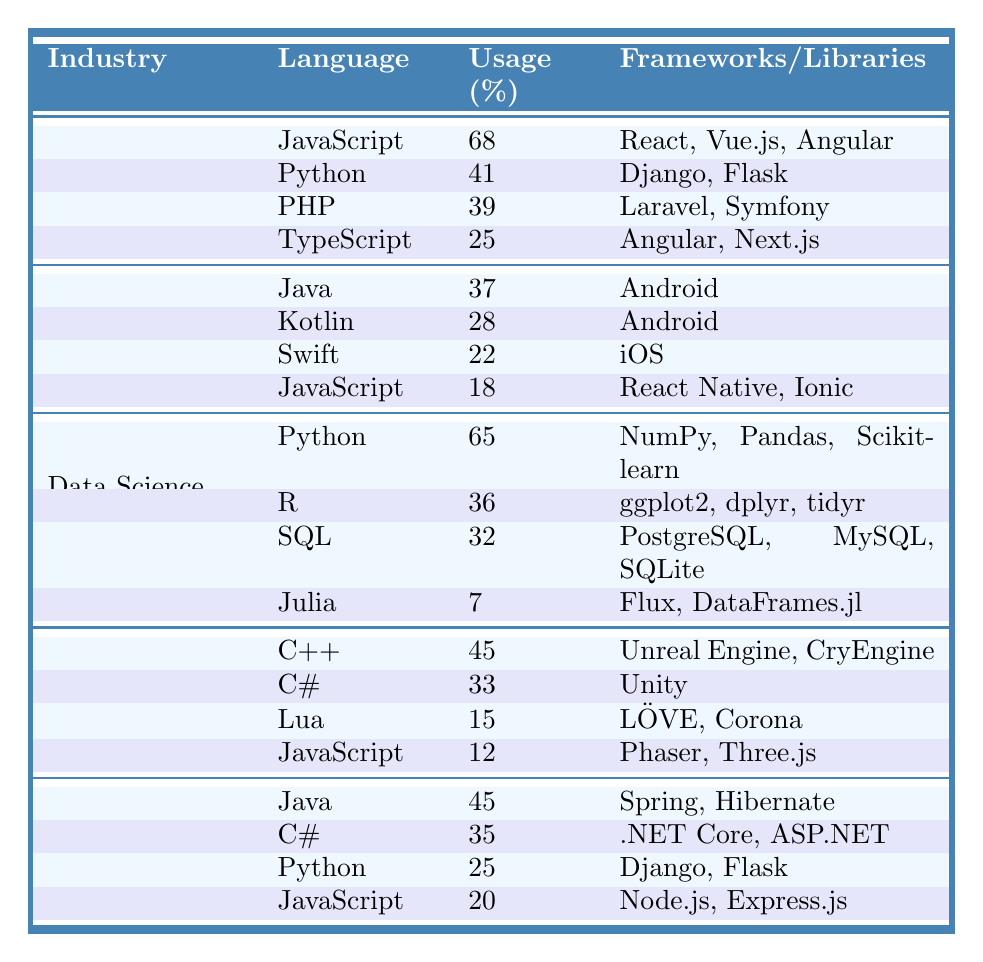What is the programming language with the highest usage in Web Development? From the table, JavaScript has the highest usage percentage of 68 in the Web Development industry.
Answer: JavaScript Which industry uses Python the most? In the table, Python is listed under both Web Development and Data Science. However, it has a higher usage percentage of 65 in Data Science, making it the industry where Python is used the most.
Answer: Data Science What is the total usage percentage of Java in both Mobile App Development and Enterprise Software? Java's usage in Mobile App Development is 37 and in Enterprise Software is 45. Adding these together gives 37 + 45 = 82.
Answer: 82 How many Frameworks are listed for C# in the Enterprise Software industry? The table shows that C# is associated with two frameworks: .NET Core and ASP.NET in Enterprise Software.
Answer: 2 Is JavaScript used in Game Development? Yes, the table includes JavaScript in the Game Development industry with a usage percentage of 12.
Answer: Yes Which language has the lowest usage in the Data Science industry? The table indicates that Julia has the lowest usage percentage of 7 among the listed languages in the Data Science industry.
Answer: Julia What is the average usage percentage of all languages in Mobile App Development? The languages in this industry are Java (37), Kotlin (28), Swift (22), and JavaScript (18). Adding them gives 37 + 28 + 22 + 18 = 105, and dividing by 4 gives an average of 105 / 4 = 26.25.
Answer: 26.25 How does the usage of JavaScript in Web Development compare to its usage in Mobile App Development? JavaScript has a usage percentage of 68 in Web Development and 18 in Mobile App Development. The difference is 68 - 18 = 50, indicating that it is more utilized in Web Development.
Answer: More in Web Development Which industry has a higher usage of C++: Game Development or Enterprise Software? Game Development lists C++ with a usage percentage of 45, while Enterprise Software does not list C++. Thus, C++ is exclusively in Game Development with a higher usage.
Answer: Game Development Is Python used in both Web Development and Data Science? Yes, the table shows Python is listed in both industries with usage percentages of 41 (Web Development) and 65 (Data Science).
Answer: Yes 